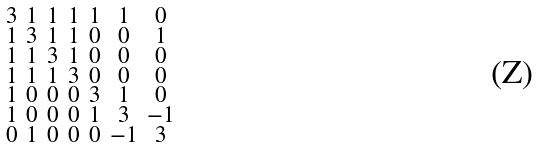<formula> <loc_0><loc_0><loc_500><loc_500>\begin{smallmatrix} 3 & 1 & 1 & 1 & 1 & 1 & 0 \\ 1 & 3 & 1 & 1 & 0 & 0 & 1 \\ 1 & 1 & 3 & 1 & 0 & 0 & 0 \\ 1 & 1 & 1 & 3 & 0 & 0 & 0 \\ 1 & 0 & 0 & 0 & 3 & 1 & 0 \\ 1 & 0 & 0 & 0 & 1 & 3 & - 1 \\ 0 & 1 & 0 & 0 & 0 & - 1 & 3 \end{smallmatrix}</formula> 